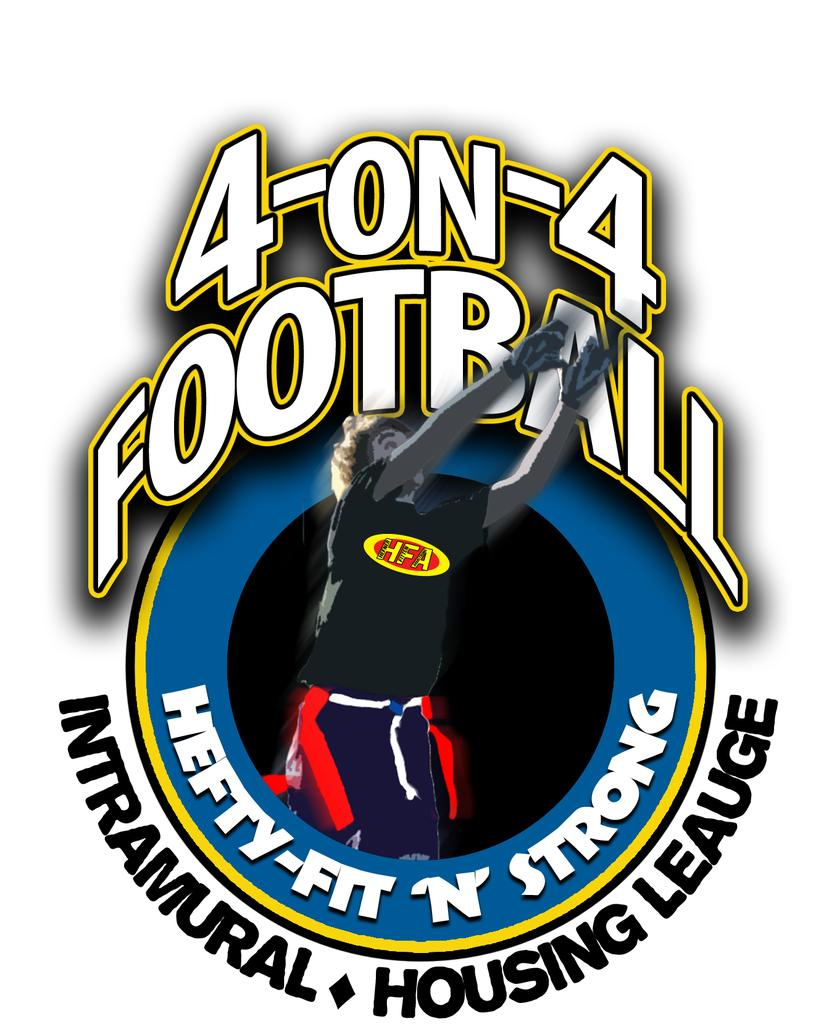<image>
Present a compact description of the photo's key features. Logo which shows a soccer player and the words Hefty-Fit n Strong. 